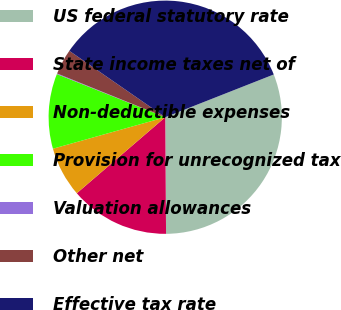Convert chart to OTSL. <chart><loc_0><loc_0><loc_500><loc_500><pie_chart><fcel>US federal statutory rate<fcel>State income taxes net of<fcel>Non-deductible expenses<fcel>Provision for unrecognized tax<fcel>Valuation allowances<fcel>Other net<fcel>Effective tax rate<nl><fcel>30.86%<fcel>13.81%<fcel>6.95%<fcel>10.38%<fcel>0.09%<fcel>3.52%<fcel>34.39%<nl></chart> 